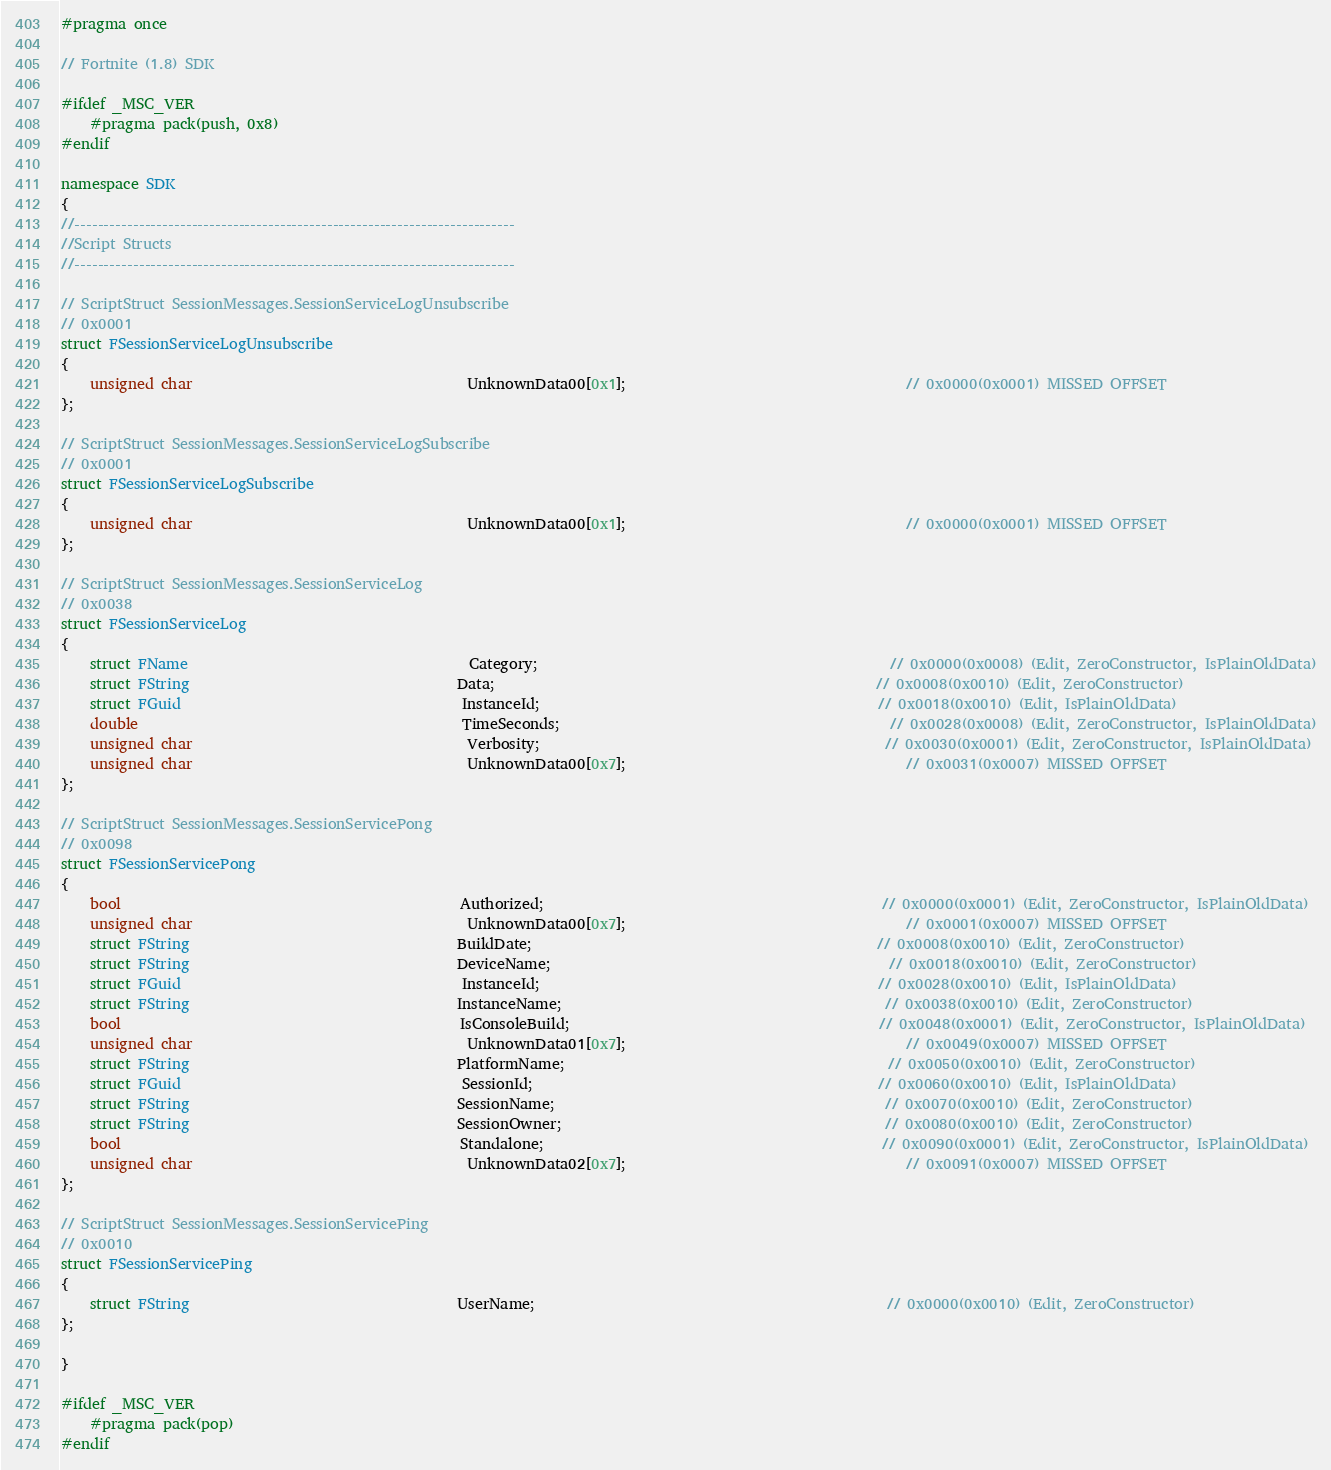<code> <loc_0><loc_0><loc_500><loc_500><_C++_>#pragma once

// Fortnite (1.8) SDK

#ifdef _MSC_VER
	#pragma pack(push, 0x8)
#endif

namespace SDK
{
//---------------------------------------------------------------------------
//Script Structs
//---------------------------------------------------------------------------

// ScriptStruct SessionMessages.SessionServiceLogUnsubscribe
// 0x0001
struct FSessionServiceLogUnsubscribe
{
	unsigned char                                      UnknownData00[0x1];                                       // 0x0000(0x0001) MISSED OFFSET
};

// ScriptStruct SessionMessages.SessionServiceLogSubscribe
// 0x0001
struct FSessionServiceLogSubscribe
{
	unsigned char                                      UnknownData00[0x1];                                       // 0x0000(0x0001) MISSED OFFSET
};

// ScriptStruct SessionMessages.SessionServiceLog
// 0x0038
struct FSessionServiceLog
{
	struct FName                                       Category;                                                 // 0x0000(0x0008) (Edit, ZeroConstructor, IsPlainOldData)
	struct FString                                     Data;                                                     // 0x0008(0x0010) (Edit, ZeroConstructor)
	struct FGuid                                       InstanceId;                                               // 0x0018(0x0010) (Edit, IsPlainOldData)
	double                                             TimeSeconds;                                              // 0x0028(0x0008) (Edit, ZeroConstructor, IsPlainOldData)
	unsigned char                                      Verbosity;                                                // 0x0030(0x0001) (Edit, ZeroConstructor, IsPlainOldData)
	unsigned char                                      UnknownData00[0x7];                                       // 0x0031(0x0007) MISSED OFFSET
};

// ScriptStruct SessionMessages.SessionServicePong
// 0x0098
struct FSessionServicePong
{
	bool                                               Authorized;                                               // 0x0000(0x0001) (Edit, ZeroConstructor, IsPlainOldData)
	unsigned char                                      UnknownData00[0x7];                                       // 0x0001(0x0007) MISSED OFFSET
	struct FString                                     BuildDate;                                                // 0x0008(0x0010) (Edit, ZeroConstructor)
	struct FString                                     DeviceName;                                               // 0x0018(0x0010) (Edit, ZeroConstructor)
	struct FGuid                                       InstanceId;                                               // 0x0028(0x0010) (Edit, IsPlainOldData)
	struct FString                                     InstanceName;                                             // 0x0038(0x0010) (Edit, ZeroConstructor)
	bool                                               IsConsoleBuild;                                           // 0x0048(0x0001) (Edit, ZeroConstructor, IsPlainOldData)
	unsigned char                                      UnknownData01[0x7];                                       // 0x0049(0x0007) MISSED OFFSET
	struct FString                                     PlatformName;                                             // 0x0050(0x0010) (Edit, ZeroConstructor)
	struct FGuid                                       SessionId;                                                // 0x0060(0x0010) (Edit, IsPlainOldData)
	struct FString                                     SessionName;                                              // 0x0070(0x0010) (Edit, ZeroConstructor)
	struct FString                                     SessionOwner;                                             // 0x0080(0x0010) (Edit, ZeroConstructor)
	bool                                               Standalone;                                               // 0x0090(0x0001) (Edit, ZeroConstructor, IsPlainOldData)
	unsigned char                                      UnknownData02[0x7];                                       // 0x0091(0x0007) MISSED OFFSET
};

// ScriptStruct SessionMessages.SessionServicePing
// 0x0010
struct FSessionServicePing
{
	struct FString                                     UserName;                                                 // 0x0000(0x0010) (Edit, ZeroConstructor)
};

}

#ifdef _MSC_VER
	#pragma pack(pop)
#endif
</code> 